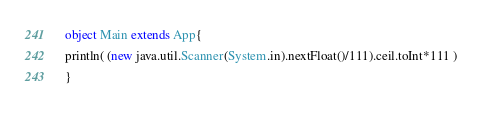Convert code to text. <code><loc_0><loc_0><loc_500><loc_500><_Scala_>object Main extends App{
println( (new java.util.Scanner(System.in).nextFloat()/111).ceil.toInt*111 )
}</code> 